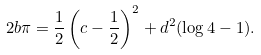<formula> <loc_0><loc_0><loc_500><loc_500>2 b \pi = \frac { 1 } { 2 } \left ( c - \frac { 1 } { 2 } \right ) ^ { 2 } + d ^ { 2 } ( \log 4 - 1 ) .</formula> 